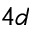<formula> <loc_0><loc_0><loc_500><loc_500>4 d</formula> 